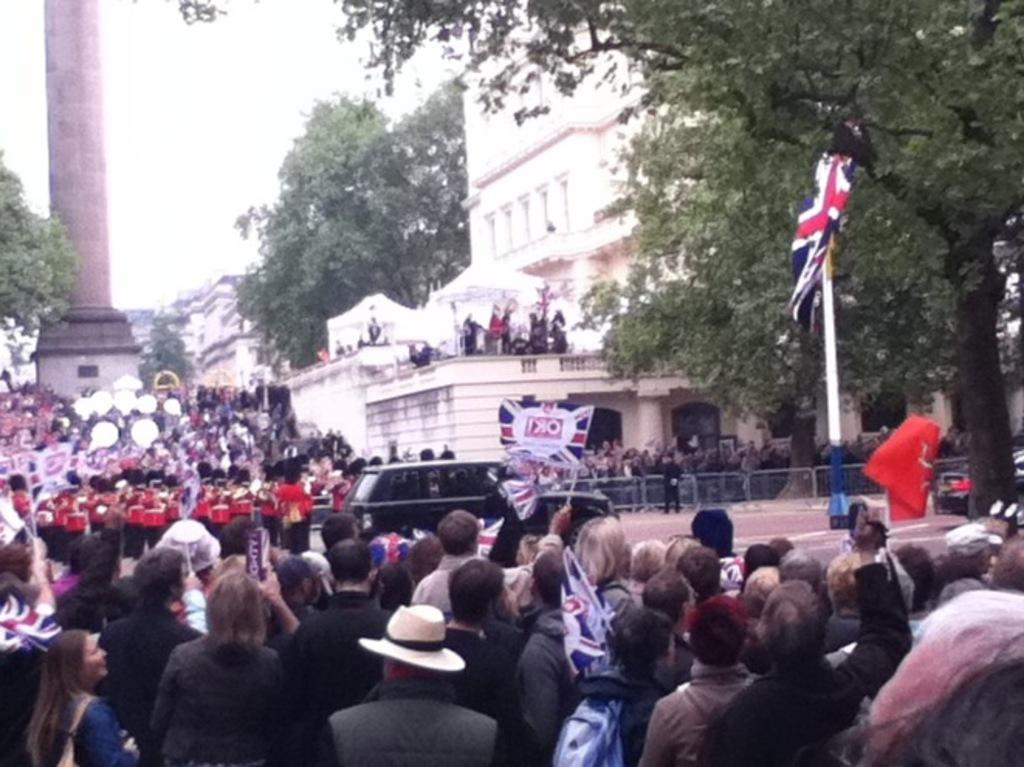How many people can be seen in the image? There are many people in the image. What can be seen in the image besides people? Flags, lights, trees, a tower, buildings, tents for shelter, a car, and barriers are visible in the image. What is the purpose of the barriers in the image? The barriers in the image may be used for crowd control or to direct the flow of people. What is visible in the sky in the image? The sky is visible in the image. Can you tell me which doctor is treating the patient in the image? There is no doctor or patient present in the image. What type of smile can be seen on the faces of the people in the image? There is no information about the expressions of the people in the image, so it cannot be determined if they are smiling. 